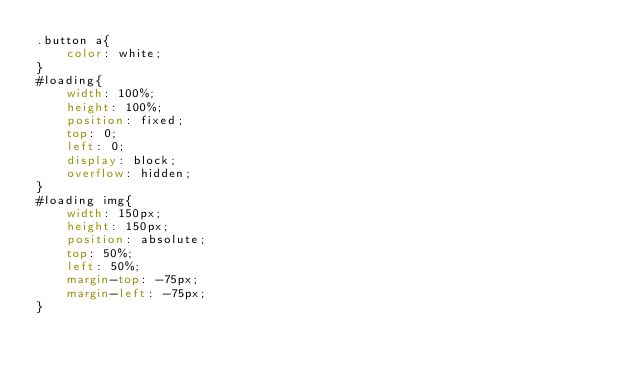<code> <loc_0><loc_0><loc_500><loc_500><_CSS_>.button a{
    color: white;
}
#loading{
    width: 100%;
    height: 100%;
    position: fixed;
    top: 0;
    left: 0;
    display: block;
    overflow: hidden;
}
#loading img{
    width: 150px;
    height: 150px;
    position: absolute;
    top: 50%;
    left: 50%;
    margin-top: -75px;
    margin-left: -75px;
}
</code> 